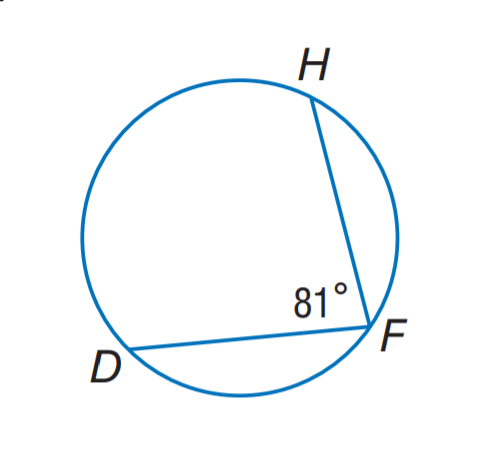Question: Find m \widehat D H.
Choices:
A. 81
B. 99
C. 136
D. 162
Answer with the letter. Answer: D 